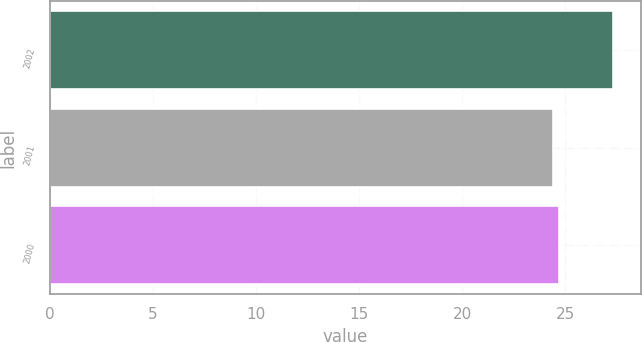Convert chart to OTSL. <chart><loc_0><loc_0><loc_500><loc_500><bar_chart><fcel>2002<fcel>2001<fcel>2000<nl><fcel>27.3<fcel>24.4<fcel>24.69<nl></chart> 